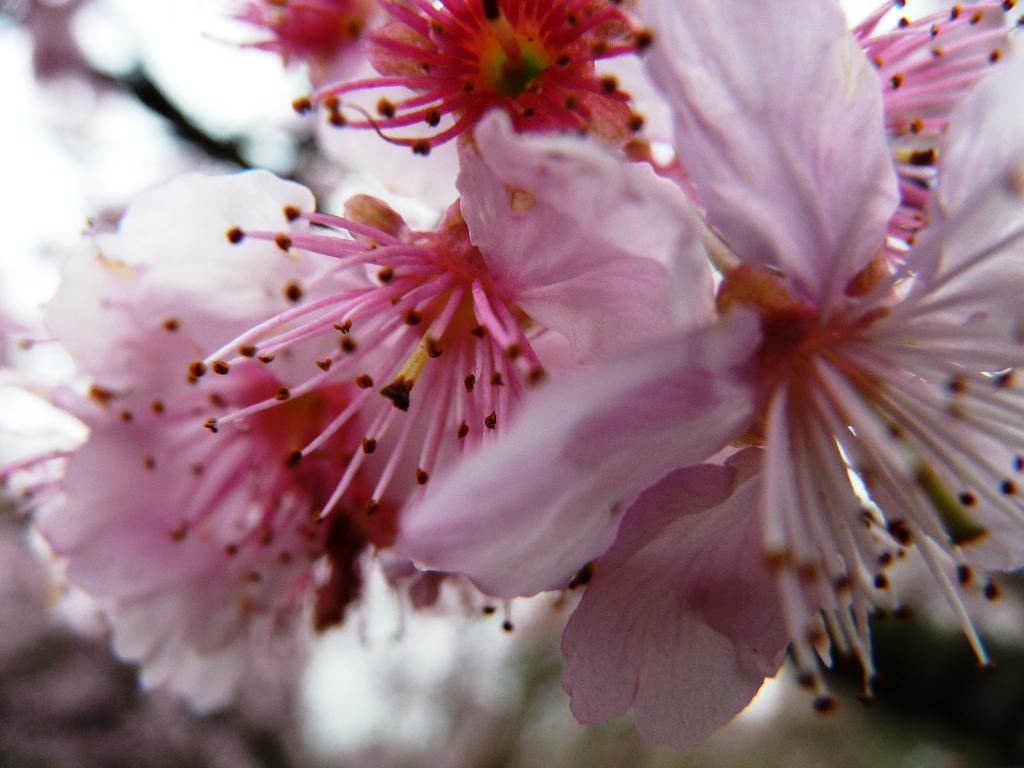What type of living organisms can be seen in the image? There are flowers in the image. What color are the flowers in the image? The flowers are pink in color. What type of church can be seen in the image? There is no church present in the image; it features pink flowers. What type of uniform is the maid wearing in the image? There is no maid present in the image; it features pink flowers. 